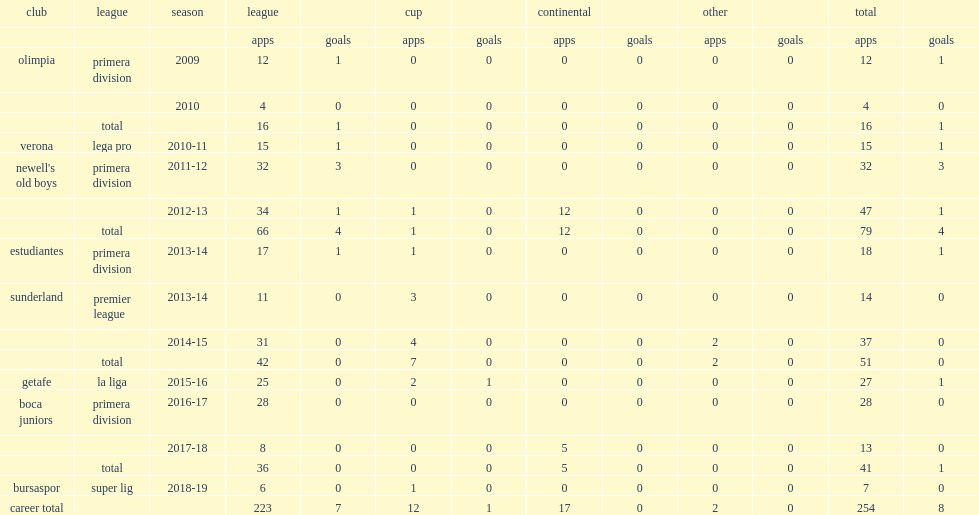Which season did vergini play for premier league side sunderland? 2013-14. 